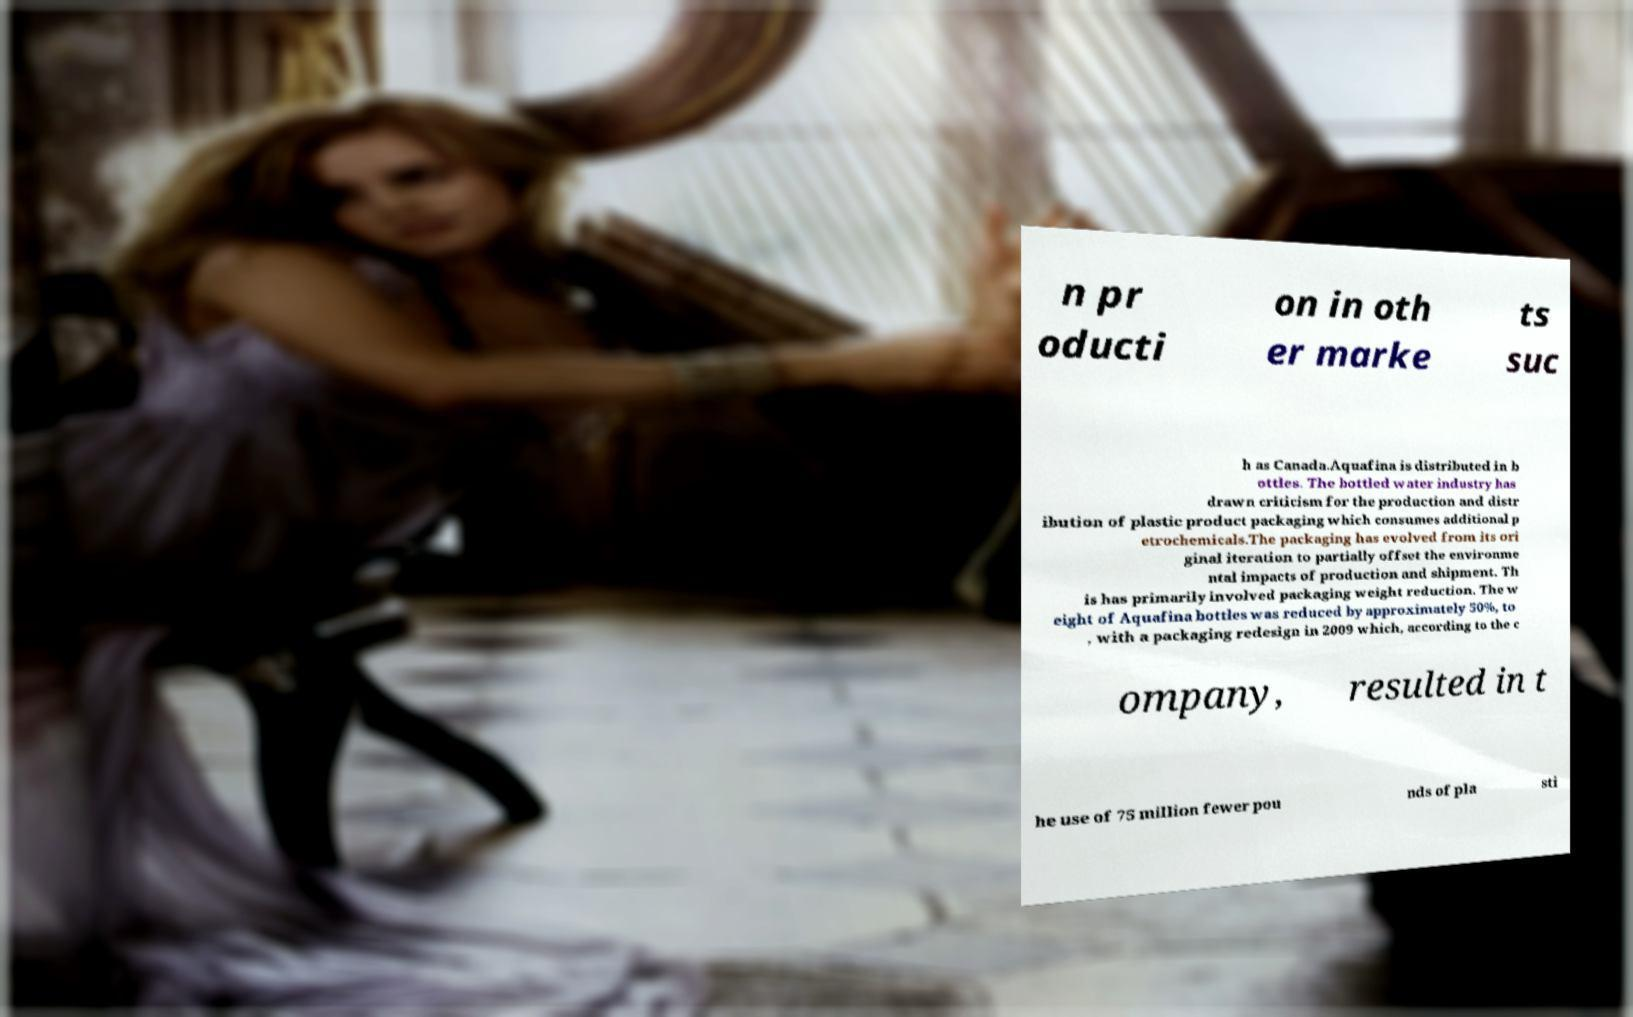Could you extract and type out the text from this image? n pr oducti on in oth er marke ts suc h as Canada.Aquafina is distributed in b ottles. The bottled water industry has drawn criticism for the production and distr ibution of plastic product packaging which consumes additional p etrochemicals.The packaging has evolved from its ori ginal iteration to partially offset the environme ntal impacts of production and shipment. Th is has primarily involved packaging weight reduction. The w eight of Aquafina bottles was reduced by approximately 50%, to , with a packaging redesign in 2009 which, according to the c ompany, resulted in t he use of 75 million fewer pou nds of pla sti 